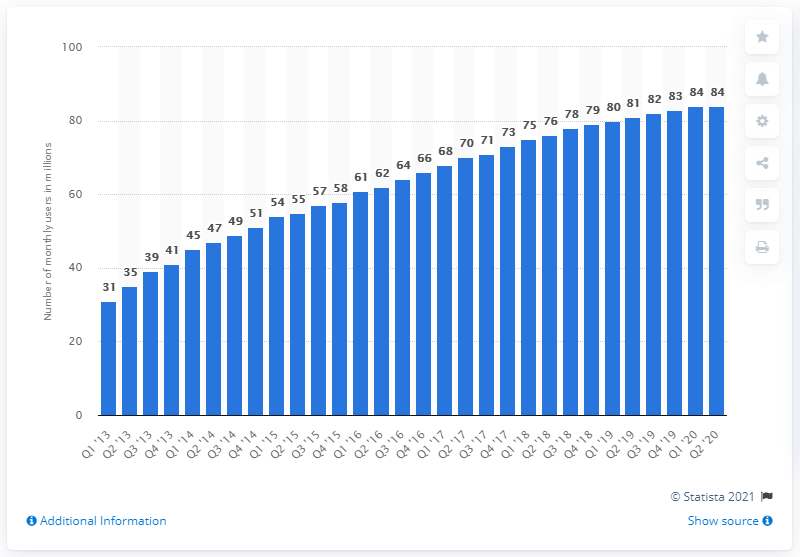List a handful of essential elements in this visual. LINE had 84 monthly active users in Japan during the fourth quarter of 2020. 